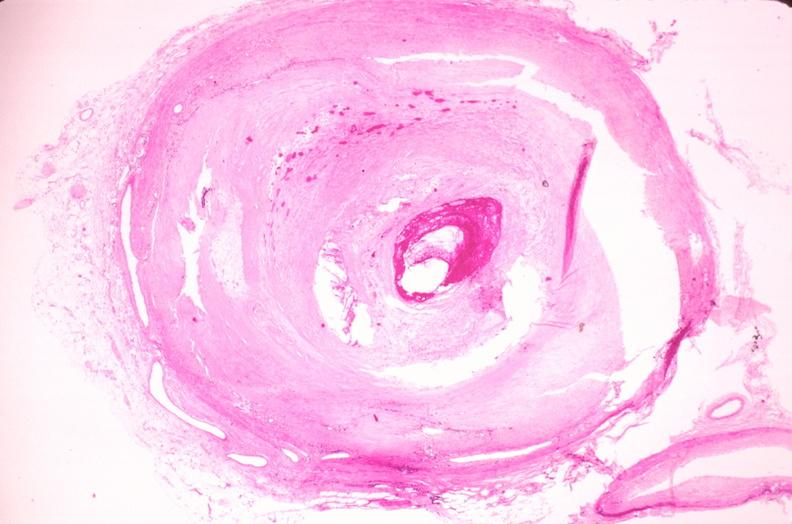s cardiovascular present?
Answer the question using a single word or phrase. Yes 